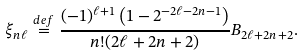Convert formula to latex. <formula><loc_0><loc_0><loc_500><loc_500>\xi _ { n \ell } \stackrel { d e f } { = } \frac { ( - 1 ) ^ { \ell + 1 } \left ( 1 - 2 ^ { - 2 \ell - 2 n - 1 } \right ) } { n ! ( 2 \ell + 2 n + 2 ) } B _ { 2 \ell + 2 n + 2 } .</formula> 